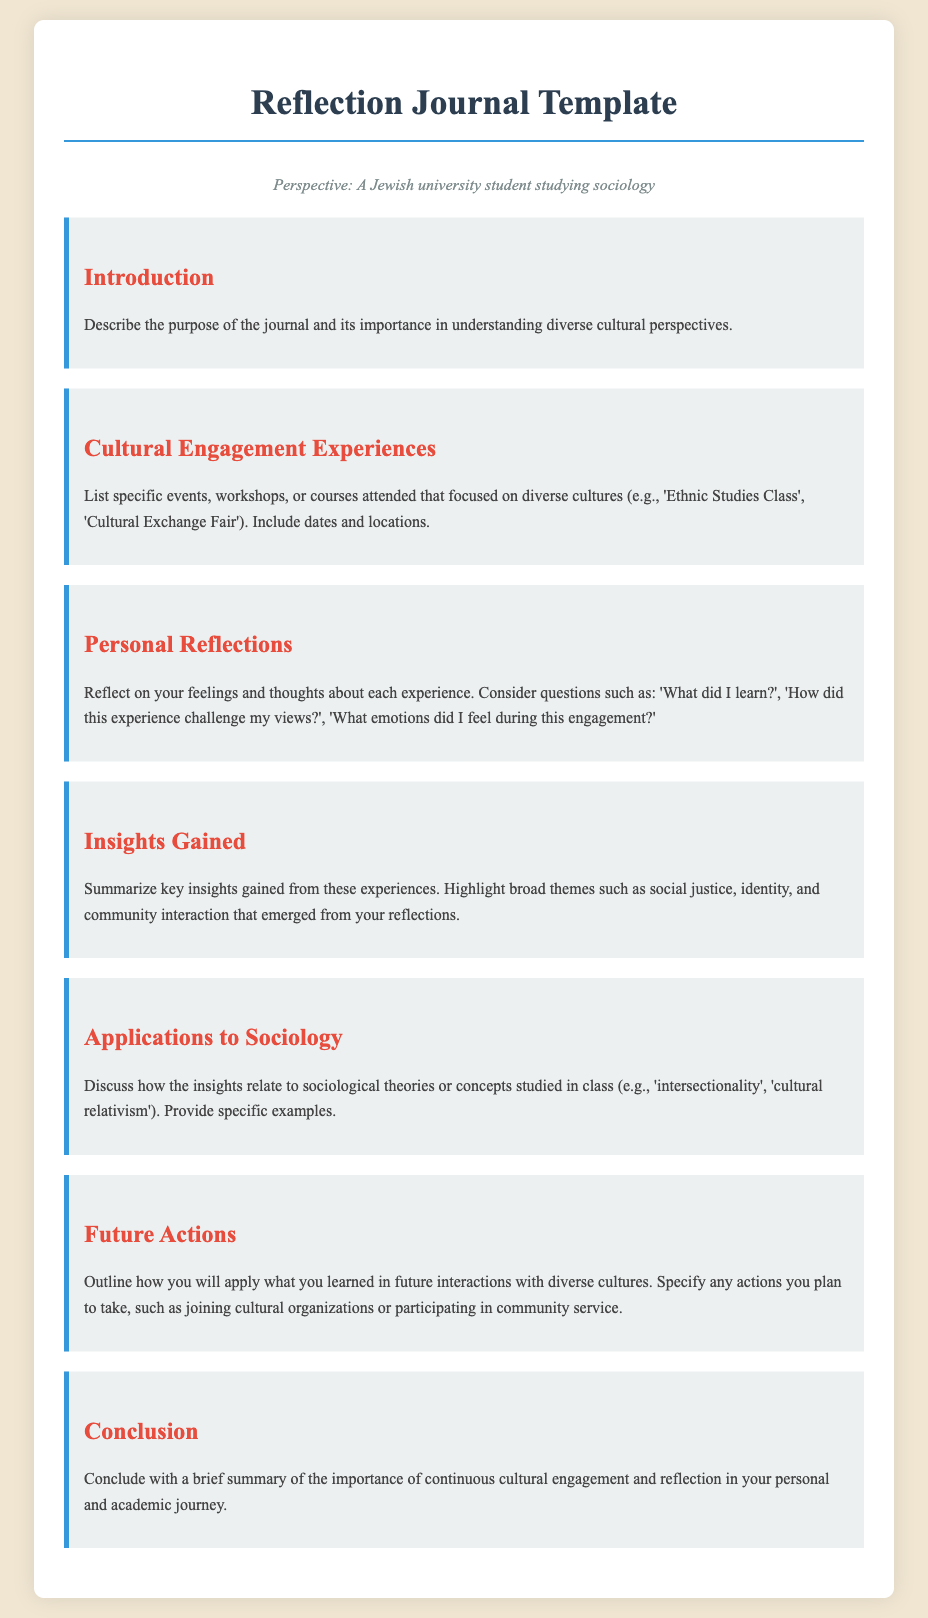what is the title of the document? The title of the document is stated in the header section of the HTML as "Reflection Journal Template".
Answer: Reflection Journal Template how many sections are there in the document? The document contains seven distinct sections, as listed under different headings.
Answer: Seven what is one suggested question for personal reflections? A recommended question for personal reflections is presented in the content section, specifically asking about emotional experiences.
Answer: What did I learn? name one theme mentioned in the insights gained section. The insights gained section highlights various broad themes, one of which is social justice.
Answer: Social justice which sociological concept is mentioned for application? The applications to sociology section refers to various sociological concepts, with one mentioned being 'intersectionality'.
Answer: Intersectionality what should be outlined in the future actions section? The future actions section emphasizes outlining plans for future engagement with diverse cultures.
Answer: Plans for future engagement what is the color of the section headings? The color of the section headings is a specific shade of red noted within the CSS styling.
Answer: Red where is the persona statement located? The persona statement is found below the document title and above the first section.
Answer: Below the title 